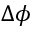Convert formula to latex. <formula><loc_0><loc_0><loc_500><loc_500>\Delta \phi</formula> 